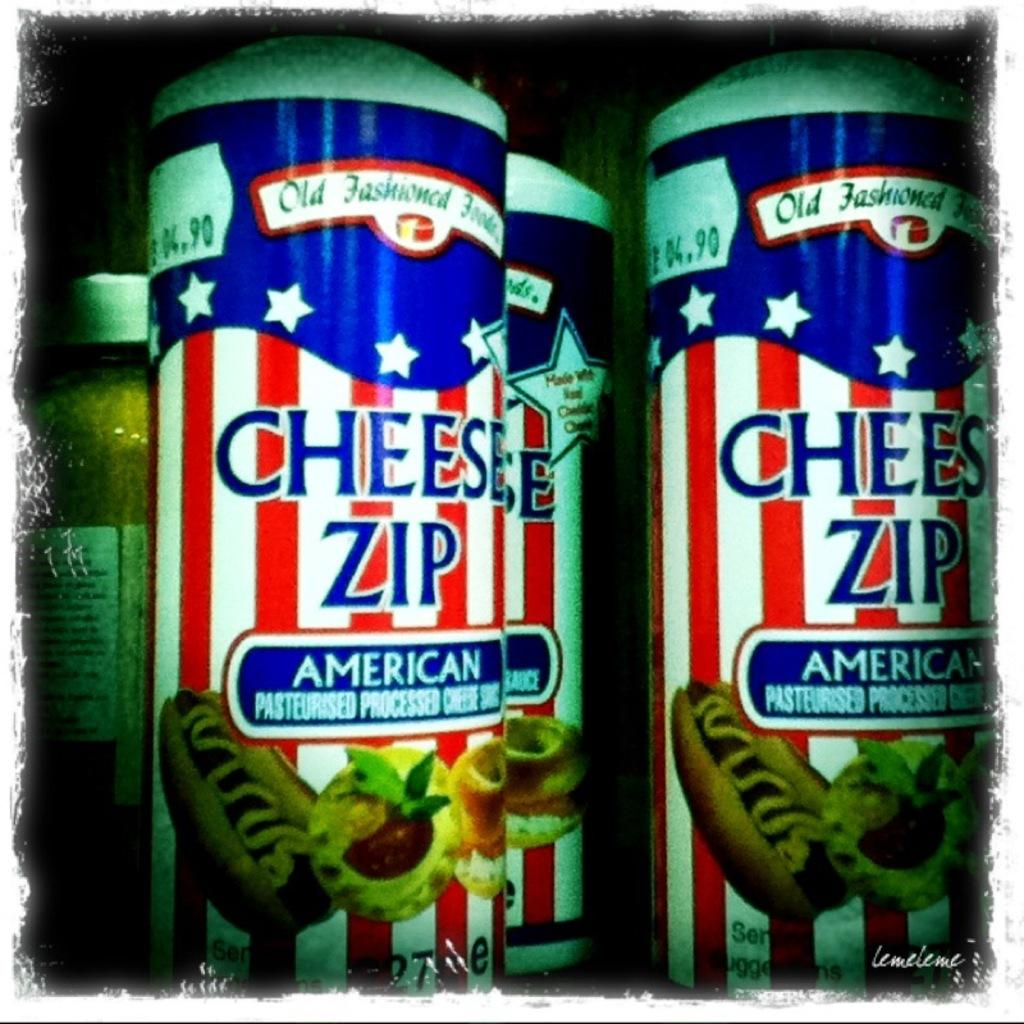<image>
Describe the image concisely. Several cans of a product called Cheese Zip. 